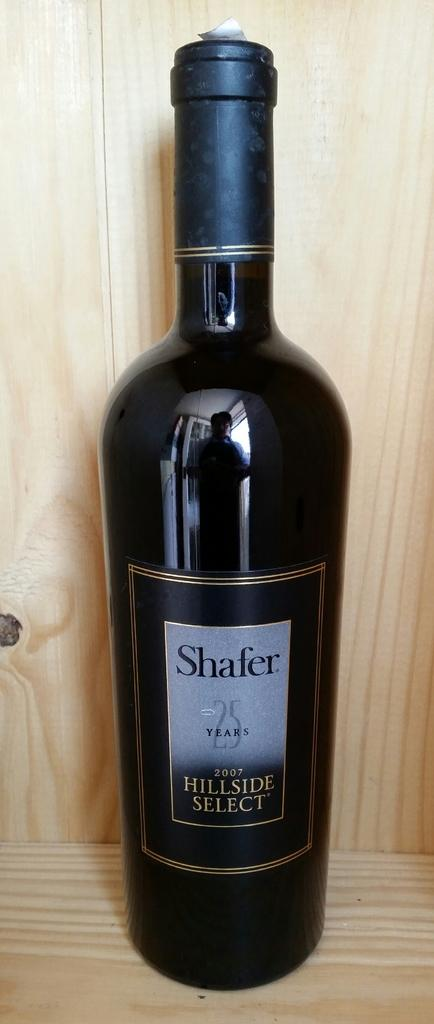Provide a one-sentence caption for the provided image. A bottle of Shafer Hillside Select wine sits in a wooden cabinet. 